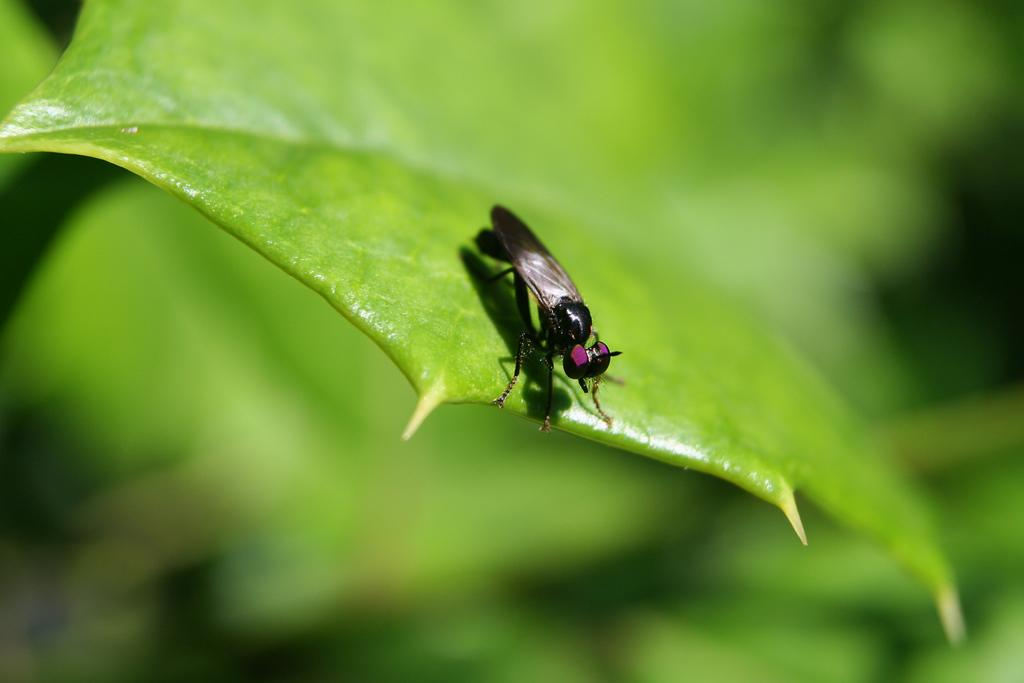What is present in the image? There is an insect in the image. What color is the insect? The insect is black in color. Where is the insect located? The insect is on a leaf. What color is the leaf? The leaf is green in color. How would you describe the background of the image? The background of the image is blurred and green in color. What type of square can be seen in the image? There is no square present in the image; it features an insect on a leaf with a blurred green background. 